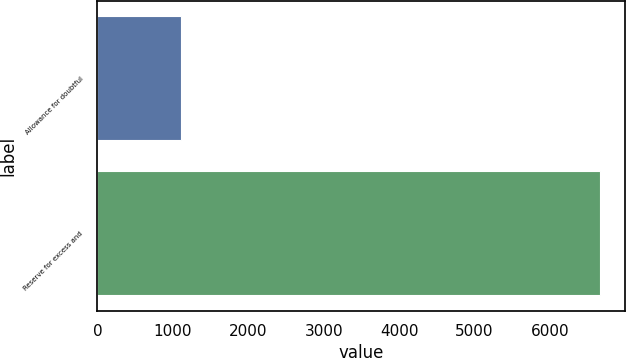Convert chart to OTSL. <chart><loc_0><loc_0><loc_500><loc_500><bar_chart><fcel>Allowance for doubtful<fcel>Reserve for excess and<nl><fcel>1110<fcel>6657<nl></chart> 